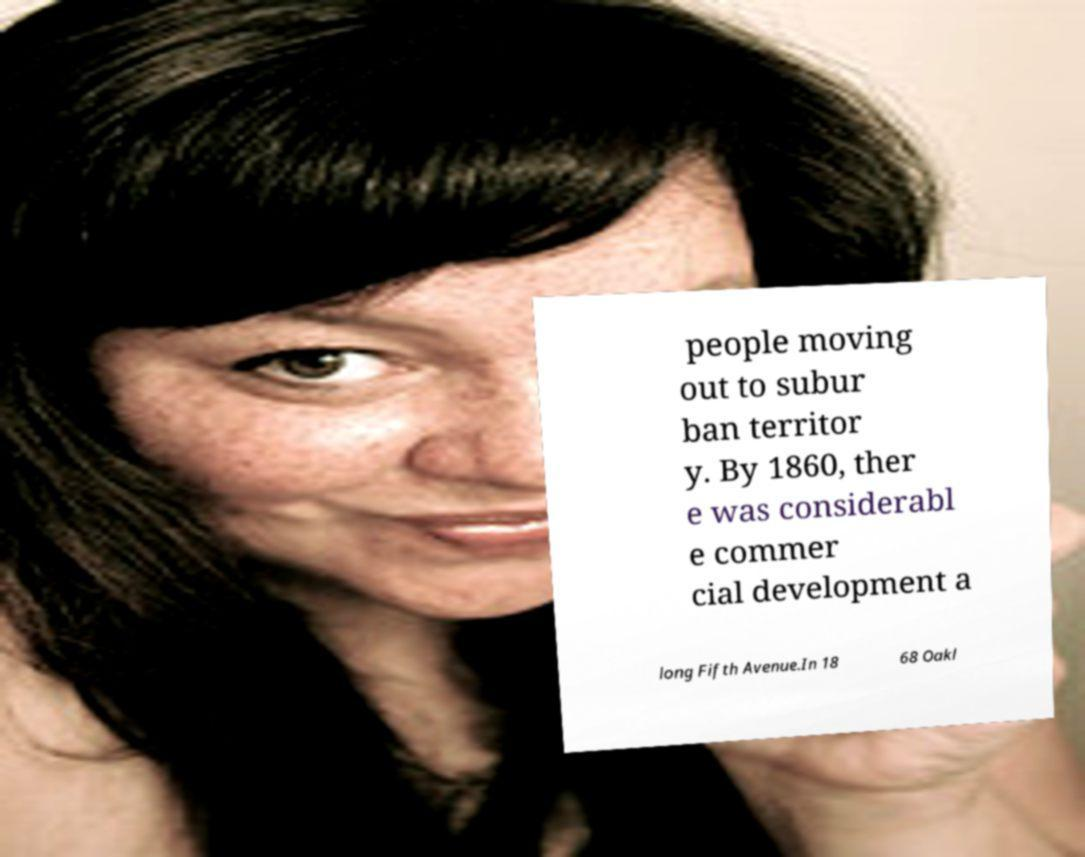Can you read and provide the text displayed in the image?This photo seems to have some interesting text. Can you extract and type it out for me? people moving out to subur ban territor y. By 1860, ther e was considerabl e commer cial development a long Fifth Avenue.In 18 68 Oakl 